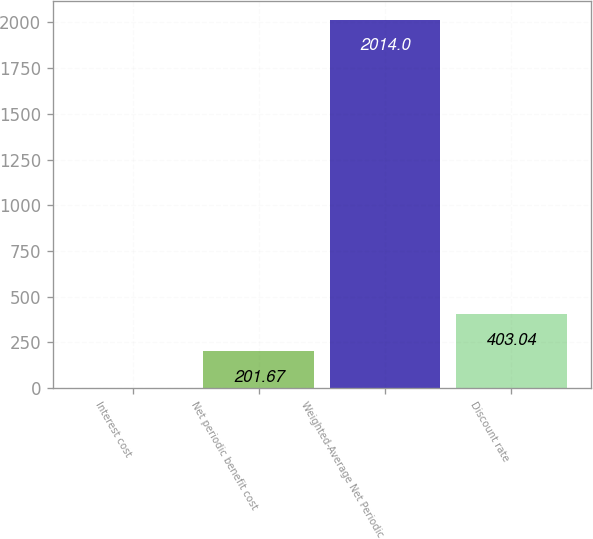Convert chart to OTSL. <chart><loc_0><loc_0><loc_500><loc_500><bar_chart><fcel>Interest cost<fcel>Net periodic benefit cost<fcel>Weighted-Average Net Periodic<fcel>Discount rate<nl><fcel>0.3<fcel>201.67<fcel>2014<fcel>403.04<nl></chart> 